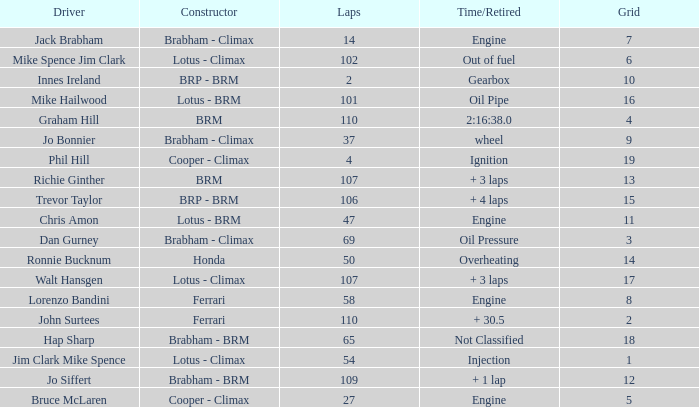What time/retired for grid 18? Not Classified. 